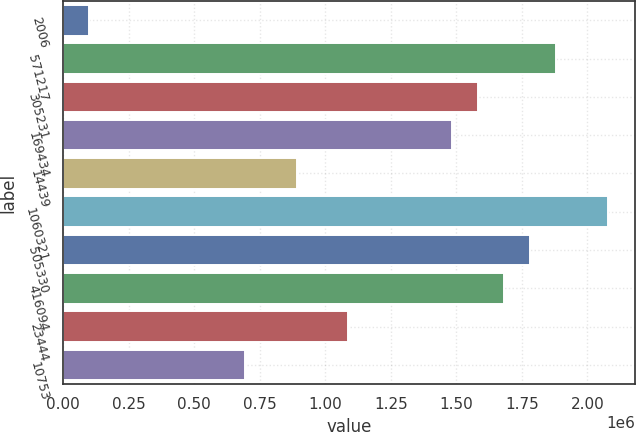Convert chart to OTSL. <chart><loc_0><loc_0><loc_500><loc_500><bar_chart><fcel>2006<fcel>571217<fcel>305231<fcel>169434<fcel>14439<fcel>1060321<fcel>505330<fcel>416094<fcel>23444<fcel>10753<nl><fcel>98900.4<fcel>1.87911e+06<fcel>1.58241e+06<fcel>1.48351e+06<fcel>890104<fcel>2.07691e+06<fcel>1.78021e+06<fcel>1.68131e+06<fcel>1.0879e+06<fcel>692303<nl></chart> 